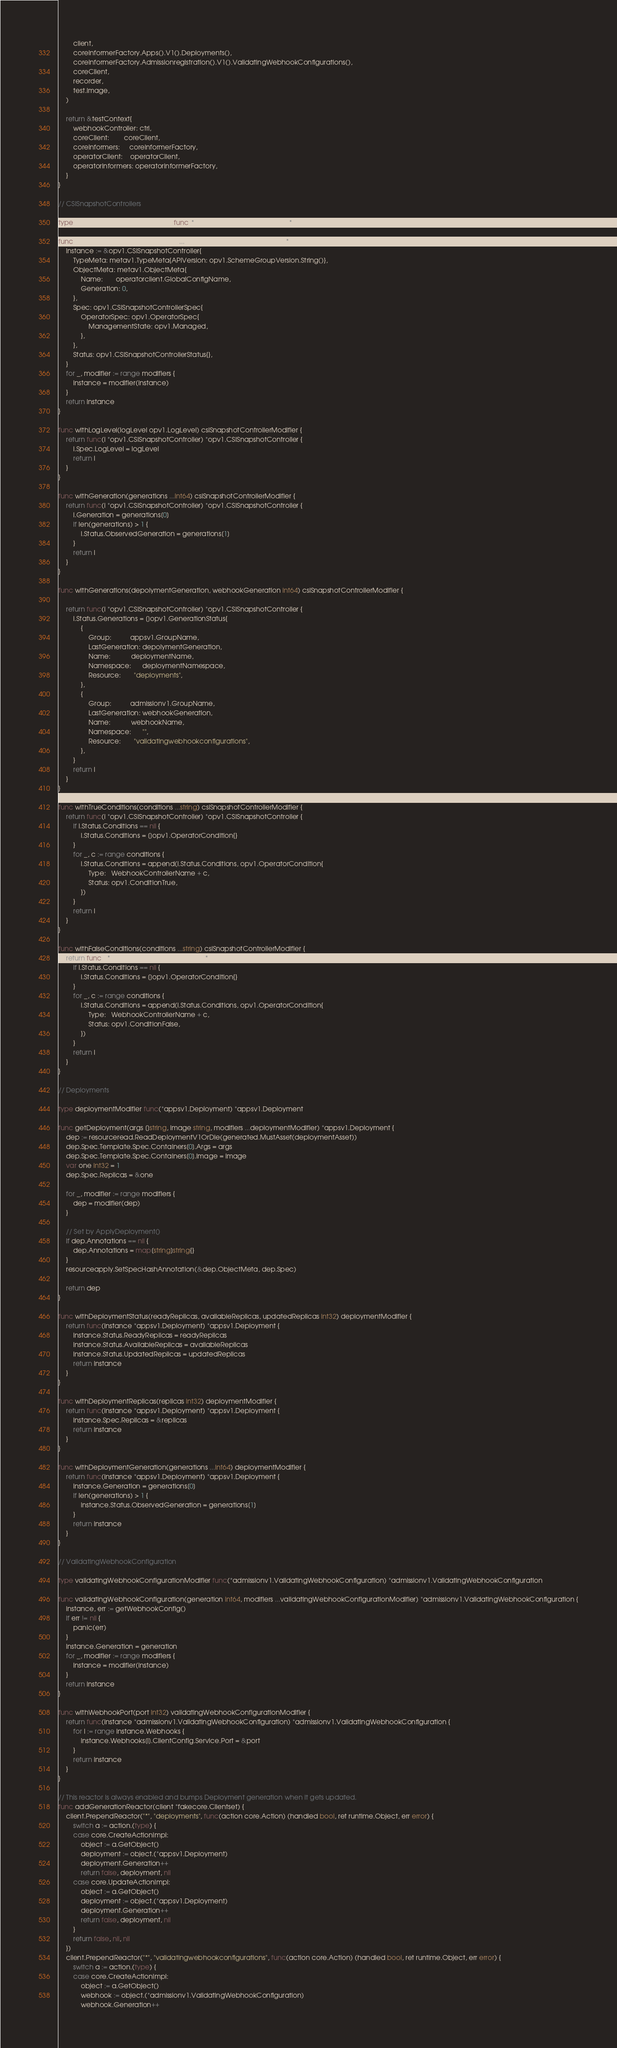<code> <loc_0><loc_0><loc_500><loc_500><_Go_>		client,
		coreInformerFactory.Apps().V1().Deployments(),
		coreInformerFactory.Admissionregistration().V1().ValidatingWebhookConfigurations(),
		coreClient,
		recorder,
		test.image,
	)

	return &testContext{
		webhookController: ctrl,
		coreClient:        coreClient,
		coreInformers:     coreInformerFactory,
		operatorClient:    operatorClient,
		operatorInformers: operatorInformerFactory,
	}
}

// CSISnapshotControllers

type csiSnapshotControllerModifier func(*opv1.CSISnapshotController) *opv1.CSISnapshotController

func csiSnapshotController(modifiers ...csiSnapshotControllerModifier) *opv1.CSISnapshotController {
	instance := &opv1.CSISnapshotController{
		TypeMeta: metav1.TypeMeta{APIVersion: opv1.SchemeGroupVersion.String()},
		ObjectMeta: metav1.ObjectMeta{
			Name:       operatorclient.GlobalConfigName,
			Generation: 0,
		},
		Spec: opv1.CSISnapshotControllerSpec{
			OperatorSpec: opv1.OperatorSpec{
				ManagementState: opv1.Managed,
			},
		},
		Status: opv1.CSISnapshotControllerStatus{},
	}
	for _, modifier := range modifiers {
		instance = modifier(instance)
	}
	return instance
}

func withLogLevel(logLevel opv1.LogLevel) csiSnapshotControllerModifier {
	return func(i *opv1.CSISnapshotController) *opv1.CSISnapshotController {
		i.Spec.LogLevel = logLevel
		return i
	}
}

func withGeneration(generations ...int64) csiSnapshotControllerModifier {
	return func(i *opv1.CSISnapshotController) *opv1.CSISnapshotController {
		i.Generation = generations[0]
		if len(generations) > 1 {
			i.Status.ObservedGeneration = generations[1]
		}
		return i
	}
}

func withGenerations(depolymentGeneration, webhookGeneration int64) csiSnapshotControllerModifier {

	return func(i *opv1.CSISnapshotController) *opv1.CSISnapshotController {
		i.Status.Generations = []opv1.GenerationStatus{
			{
				Group:          appsv1.GroupName,
				LastGeneration: depolymentGeneration,
				Name:           deploymentName,
				Namespace:      deploymentNamespace,
				Resource:       "deployments",
			},
			{
				Group:          admissionv1.GroupName,
				LastGeneration: webhookGeneration,
				Name:           webhookName,
				Namespace:      "",
				Resource:       "validatingwebhookconfigurations",
			},
		}
		return i
	}
}

func withTrueConditions(conditions ...string) csiSnapshotControllerModifier {
	return func(i *opv1.CSISnapshotController) *opv1.CSISnapshotController {
		if i.Status.Conditions == nil {
			i.Status.Conditions = []opv1.OperatorCondition{}
		}
		for _, c := range conditions {
			i.Status.Conditions = append(i.Status.Conditions, opv1.OperatorCondition{
				Type:   WebhookControllerName + c,
				Status: opv1.ConditionTrue,
			})
		}
		return i
	}
}

func withFalseConditions(conditions ...string) csiSnapshotControllerModifier {
	return func(i *opv1.CSISnapshotController) *opv1.CSISnapshotController {
		if i.Status.Conditions == nil {
			i.Status.Conditions = []opv1.OperatorCondition{}
		}
		for _, c := range conditions {
			i.Status.Conditions = append(i.Status.Conditions, opv1.OperatorCondition{
				Type:   WebhookControllerName + c,
				Status: opv1.ConditionFalse,
			})
		}
		return i
	}
}

// Deployments

type deploymentModifier func(*appsv1.Deployment) *appsv1.Deployment

func getDeployment(args []string, image string, modifiers ...deploymentModifier) *appsv1.Deployment {
	dep := resourceread.ReadDeploymentV1OrDie(generated.MustAsset(deploymentAsset))
	dep.Spec.Template.Spec.Containers[0].Args = args
	dep.Spec.Template.Spec.Containers[0].Image = image
	var one int32 = 1
	dep.Spec.Replicas = &one

	for _, modifier := range modifiers {
		dep = modifier(dep)
	}

	// Set by ApplyDeployment()
	if dep.Annotations == nil {
		dep.Annotations = map[string]string{}
	}
	resourceapply.SetSpecHashAnnotation(&dep.ObjectMeta, dep.Spec)

	return dep
}

func withDeploymentStatus(readyReplicas, availableReplicas, updatedReplicas int32) deploymentModifier {
	return func(instance *appsv1.Deployment) *appsv1.Deployment {
		instance.Status.ReadyReplicas = readyReplicas
		instance.Status.AvailableReplicas = availableReplicas
		instance.Status.UpdatedReplicas = updatedReplicas
		return instance
	}
}

func withDeploymentReplicas(replicas int32) deploymentModifier {
	return func(instance *appsv1.Deployment) *appsv1.Deployment {
		instance.Spec.Replicas = &replicas
		return instance
	}
}

func withDeploymentGeneration(generations ...int64) deploymentModifier {
	return func(instance *appsv1.Deployment) *appsv1.Deployment {
		instance.Generation = generations[0]
		if len(generations) > 1 {
			instance.Status.ObservedGeneration = generations[1]
		}
		return instance
	}
}

// ValidatingWebhookConfiguration

type validatingWebhookConfigurationModifier func(*admissionv1.ValidatingWebhookConfiguration) *admissionv1.ValidatingWebhookConfiguration

func validatingWebhookConfiguration(generation int64, modifiers ...validatingWebhookConfigurationModifier) *admissionv1.ValidatingWebhookConfiguration {
	instance, err := getWebhookConfig()
	if err != nil {
		panic(err)
	}
	instance.Generation = generation
	for _, modifier := range modifiers {
		instance = modifier(instance)
	}
	return instance
}

func withWebhookPort(port int32) validatingWebhookConfigurationModifier {
	return func(instance *admissionv1.ValidatingWebhookConfiguration) *admissionv1.ValidatingWebhookConfiguration {
		for i := range instance.Webhooks {
			instance.Webhooks[i].ClientConfig.Service.Port = &port
		}
		return instance
	}
}

// This reactor is always enabled and bumps Deployment generation when it gets updated.
func addGenerationReactor(client *fakecore.Clientset) {
	client.PrependReactor("*", "deployments", func(action core.Action) (handled bool, ret runtime.Object, err error) {
		switch a := action.(type) {
		case core.CreateActionImpl:
			object := a.GetObject()
			deployment := object.(*appsv1.Deployment)
			deployment.Generation++
			return false, deployment, nil
		case core.UpdateActionImpl:
			object := a.GetObject()
			deployment := object.(*appsv1.Deployment)
			deployment.Generation++
			return false, deployment, nil
		}
		return false, nil, nil
	})
	client.PrependReactor("*", "validatingwebhookconfigurations", func(action core.Action) (handled bool, ret runtime.Object, err error) {
		switch a := action.(type) {
		case core.CreateActionImpl:
			object := a.GetObject()
			webhook := object.(*admissionv1.ValidatingWebhookConfiguration)
			webhook.Generation++</code> 